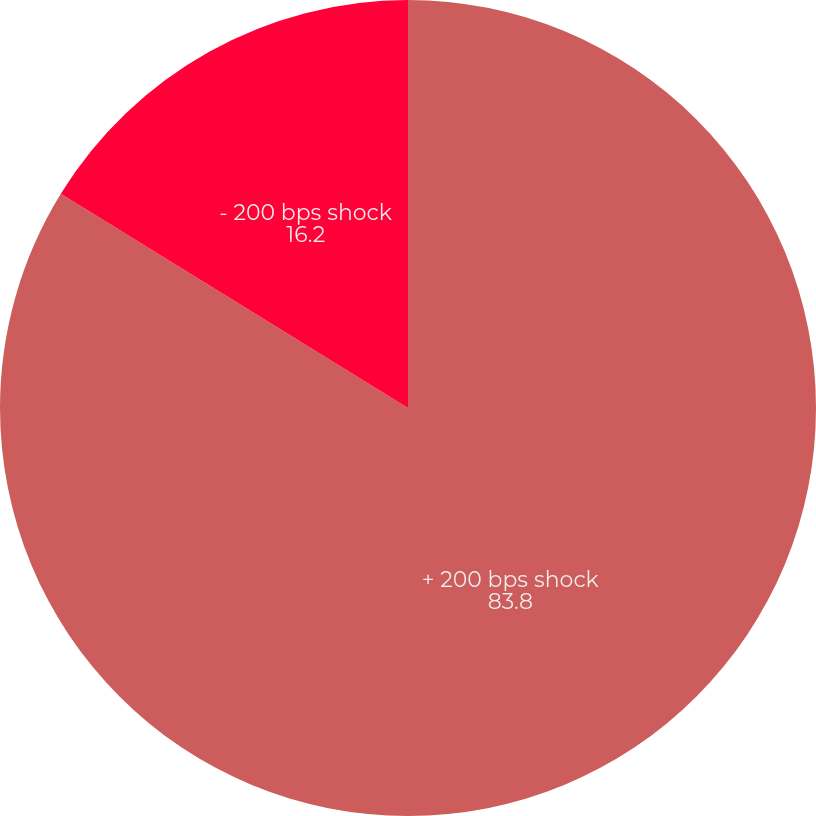Convert chart. <chart><loc_0><loc_0><loc_500><loc_500><pie_chart><fcel>+ 200 bps shock<fcel>- 200 bps shock<nl><fcel>83.8%<fcel>16.2%<nl></chart> 